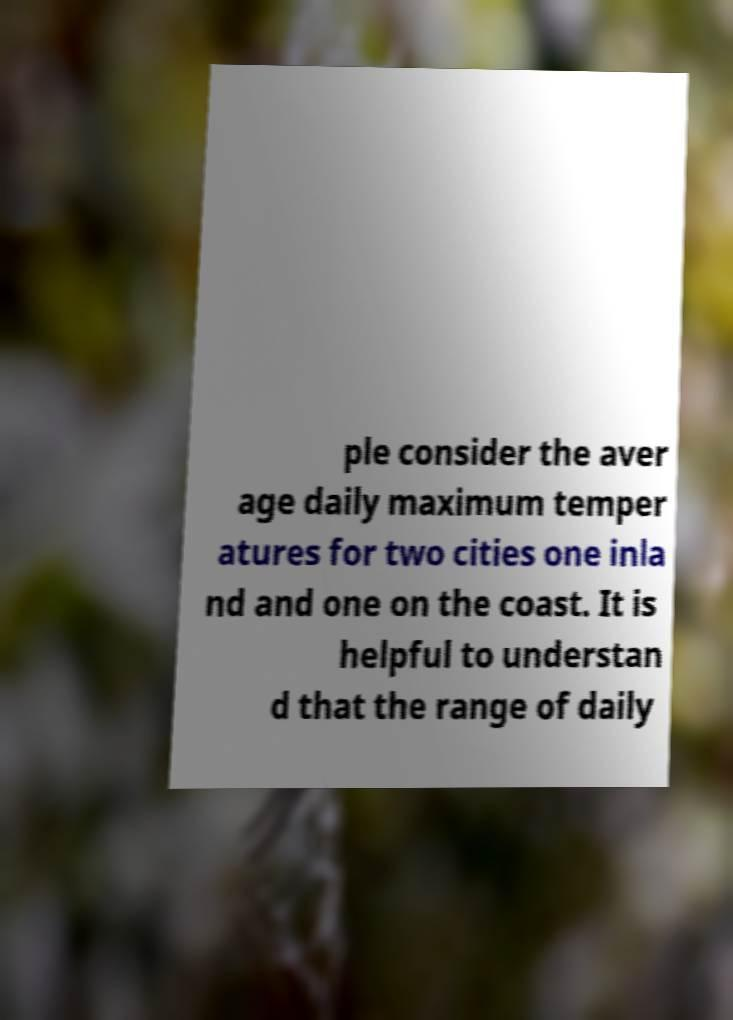Can you read and provide the text displayed in the image?This photo seems to have some interesting text. Can you extract and type it out for me? ple consider the aver age daily maximum temper atures for two cities one inla nd and one on the coast. It is helpful to understan d that the range of daily 